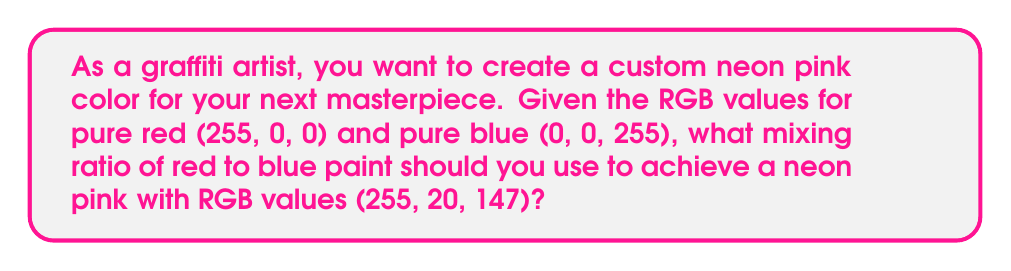Show me your answer to this math problem. To solve this problem, we need to determine the ratio of red to blue paint that will result in the desired neon pink color. We'll use the RGB values to calculate this ratio.

Step 1: Identify the relevant color components
- Red component of neon pink: 255
- Blue component of neon pink: 147

Step 2: Calculate the ratio of red to blue
Let $x$ be the fraction of red paint and $(1-x)$ be the fraction of blue paint.

The mixture can be represented by the equation:
$$ 255x + 0(1-x) = 255 $$
$$ 0x + 255(1-x) = 147 $$

Step 3: Solve for $x$ using the second equation
$$ 255 - 255x = 147 $$
$$ -255x = -108 $$
$$ x = \frac{108}{255} = 0.4235294118 $$

Step 4: Verify the result
Red component: $255 * 0.4235294118 = 108$
Blue component: $255 * (1 - 0.4235294118) = 147$

Step 5: Express the ratio
The ratio of red to blue is $0.4235294118 : (1 - 0.4235294118)$, which simplifies to:

$$ 0.4235294118 : 0.5764705882 $$

This can be further simplified to:
$$ 108 : 147 $$
Answer: 108:147 